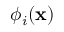<formula> <loc_0><loc_0><loc_500><loc_500>{ \phi } _ { i } ( x )</formula> 